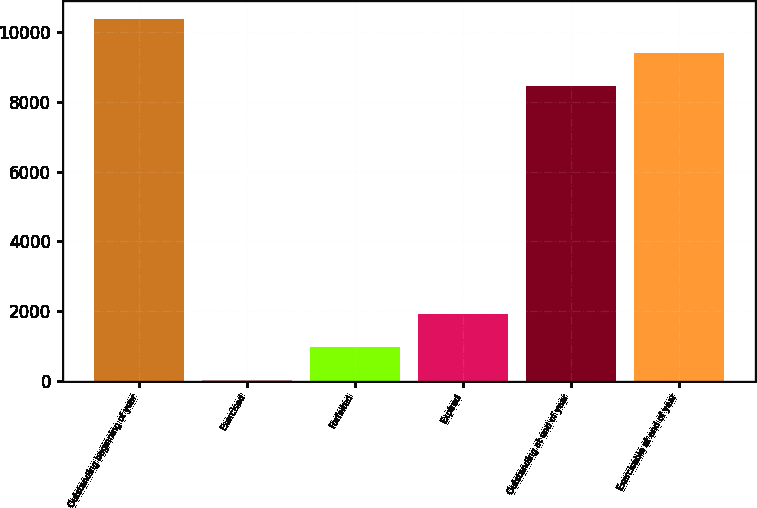<chart> <loc_0><loc_0><loc_500><loc_500><bar_chart><fcel>Outstanding beginning of year<fcel>Exercised<fcel>Forfeited<fcel>Expired<fcel>Outstanding at end of year<fcel>Exercisable at end of year<nl><fcel>10367<fcel>12<fcel>965.5<fcel>1919<fcel>8460<fcel>9413.5<nl></chart> 